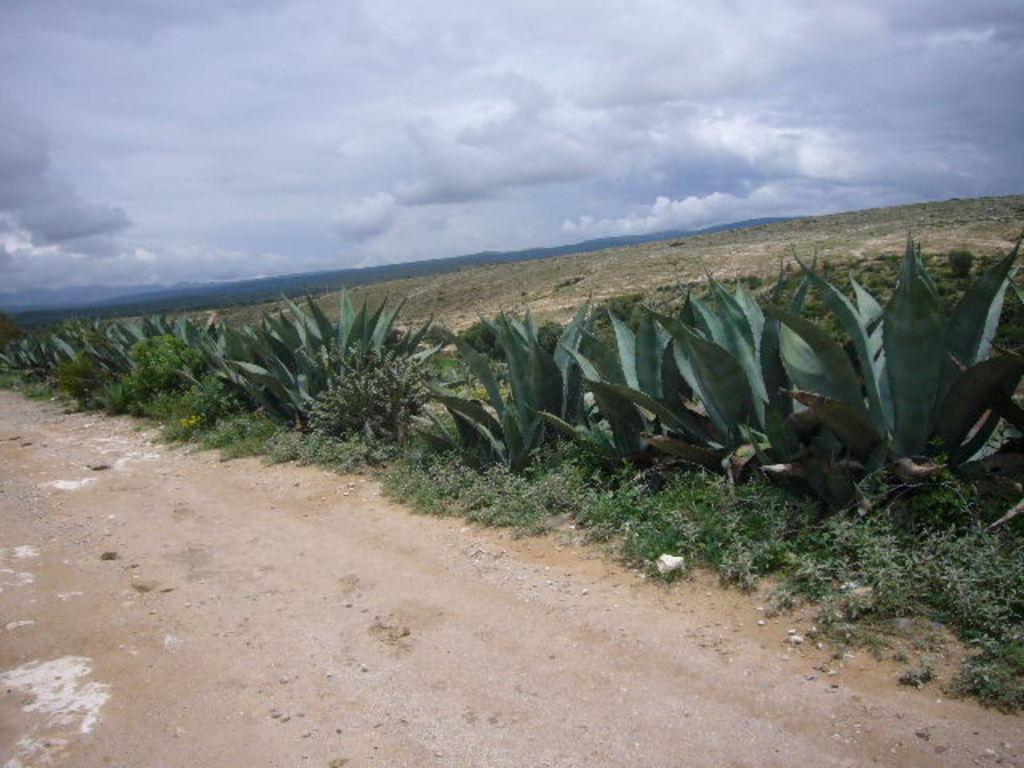Can you describe this image briefly? In this image, we can see few plants, grass. At the bottom, there is a walkway. Background there is a cloudy sky. 